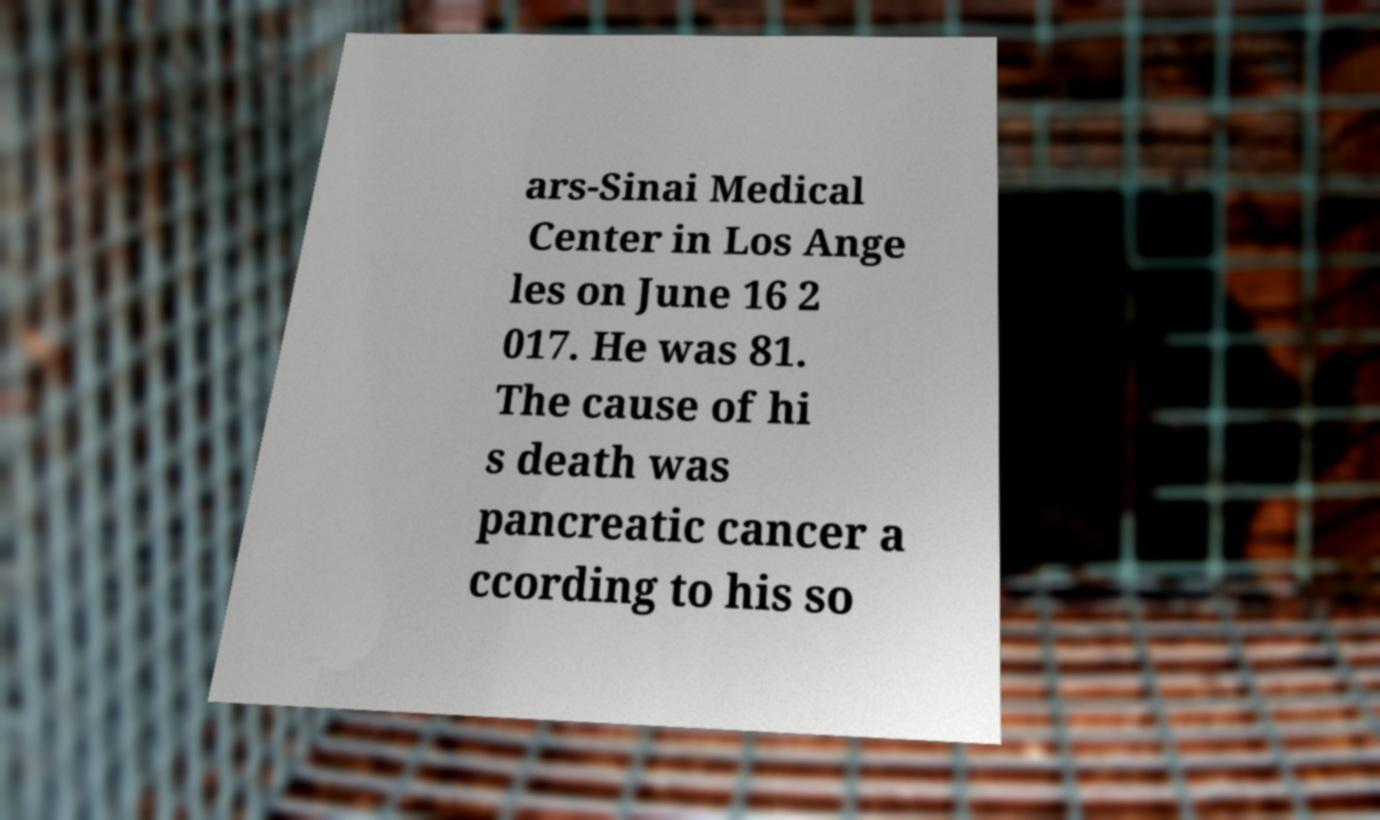What messages or text are displayed in this image? I need them in a readable, typed format. ars-Sinai Medical Center in Los Ange les on June 16 2 017. He was 81. The cause of hi s death was pancreatic cancer a ccording to his so 